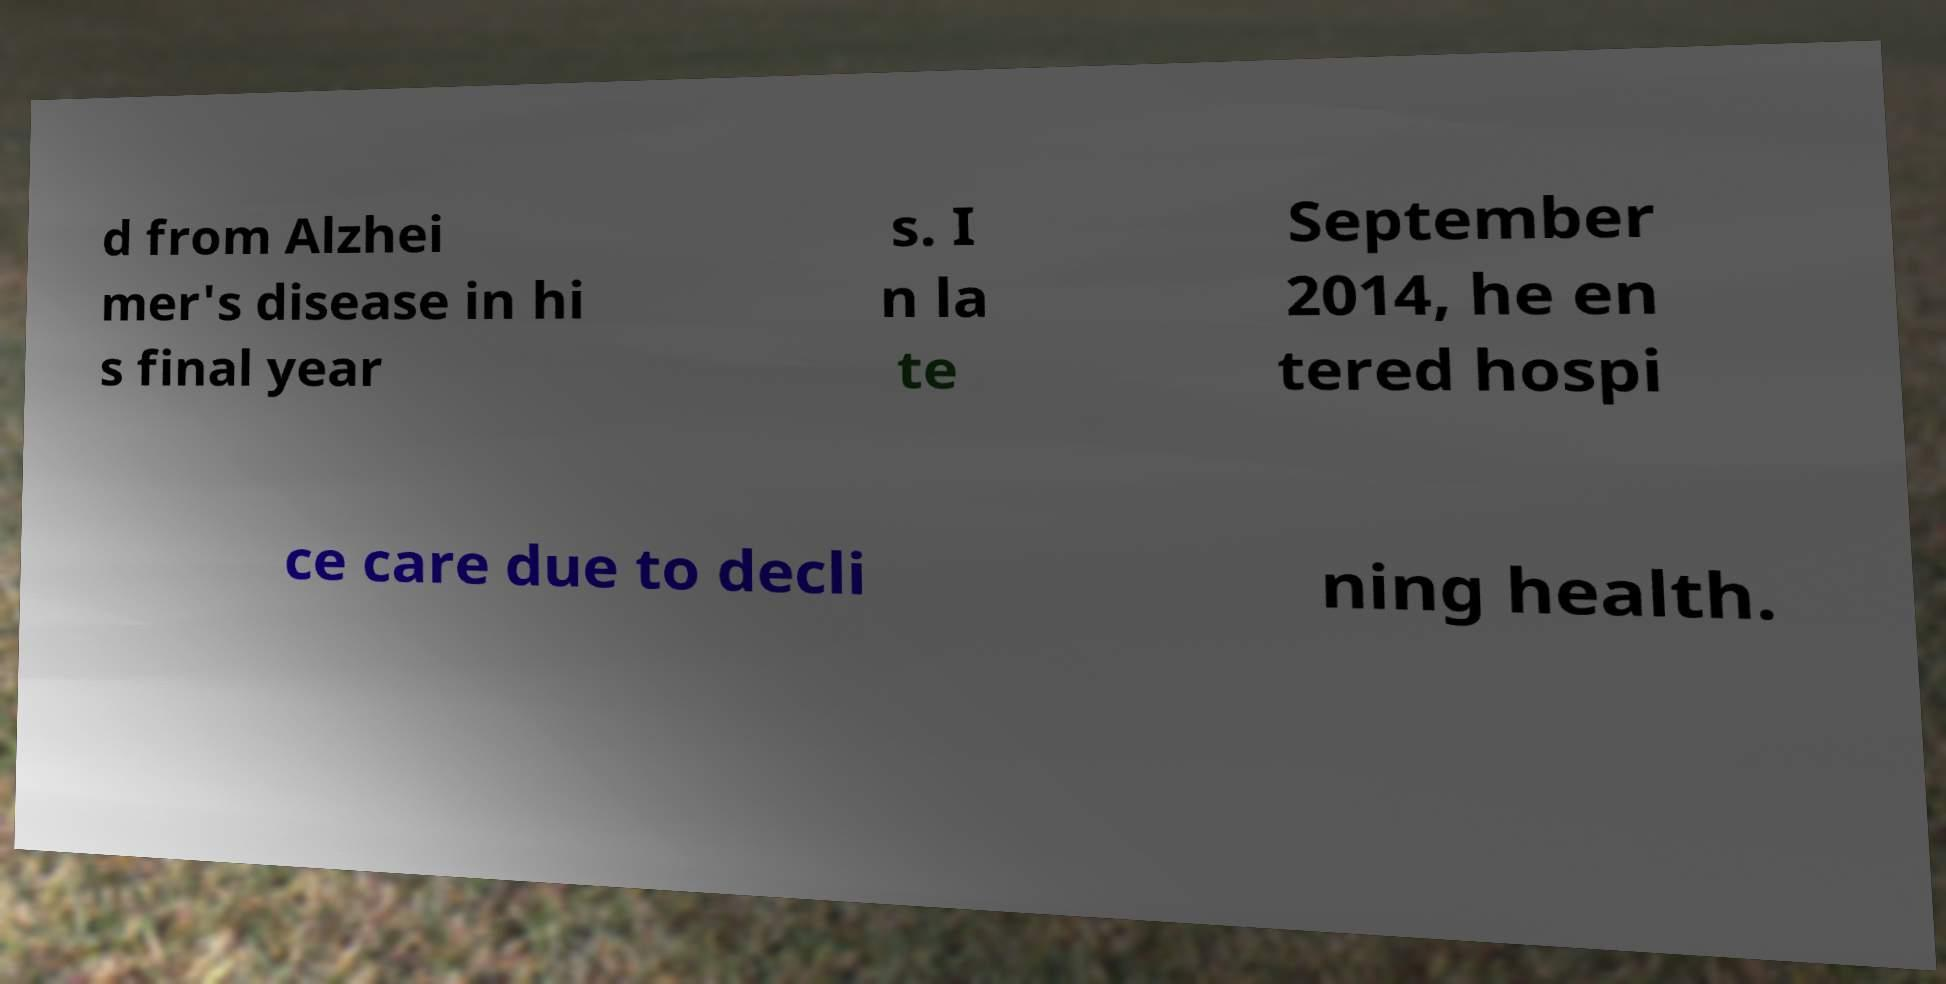Please read and relay the text visible in this image. What does it say? d from Alzhei mer's disease in hi s final year s. I n la te September 2014, he en tered hospi ce care due to decli ning health. 